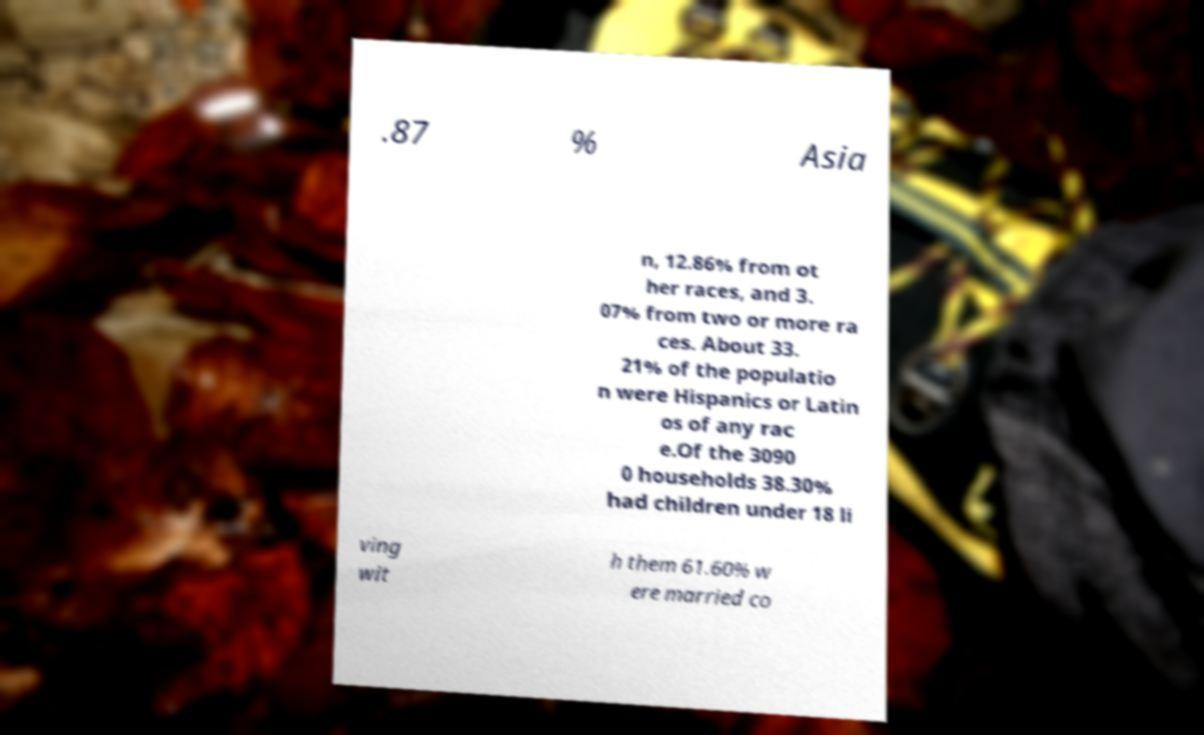What messages or text are displayed in this image? I need them in a readable, typed format. .87 % Asia n, 12.86% from ot her races, and 3. 07% from two or more ra ces. About 33. 21% of the populatio n were Hispanics or Latin os of any rac e.Of the 3090 0 households 38.30% had children under 18 li ving wit h them 61.60% w ere married co 